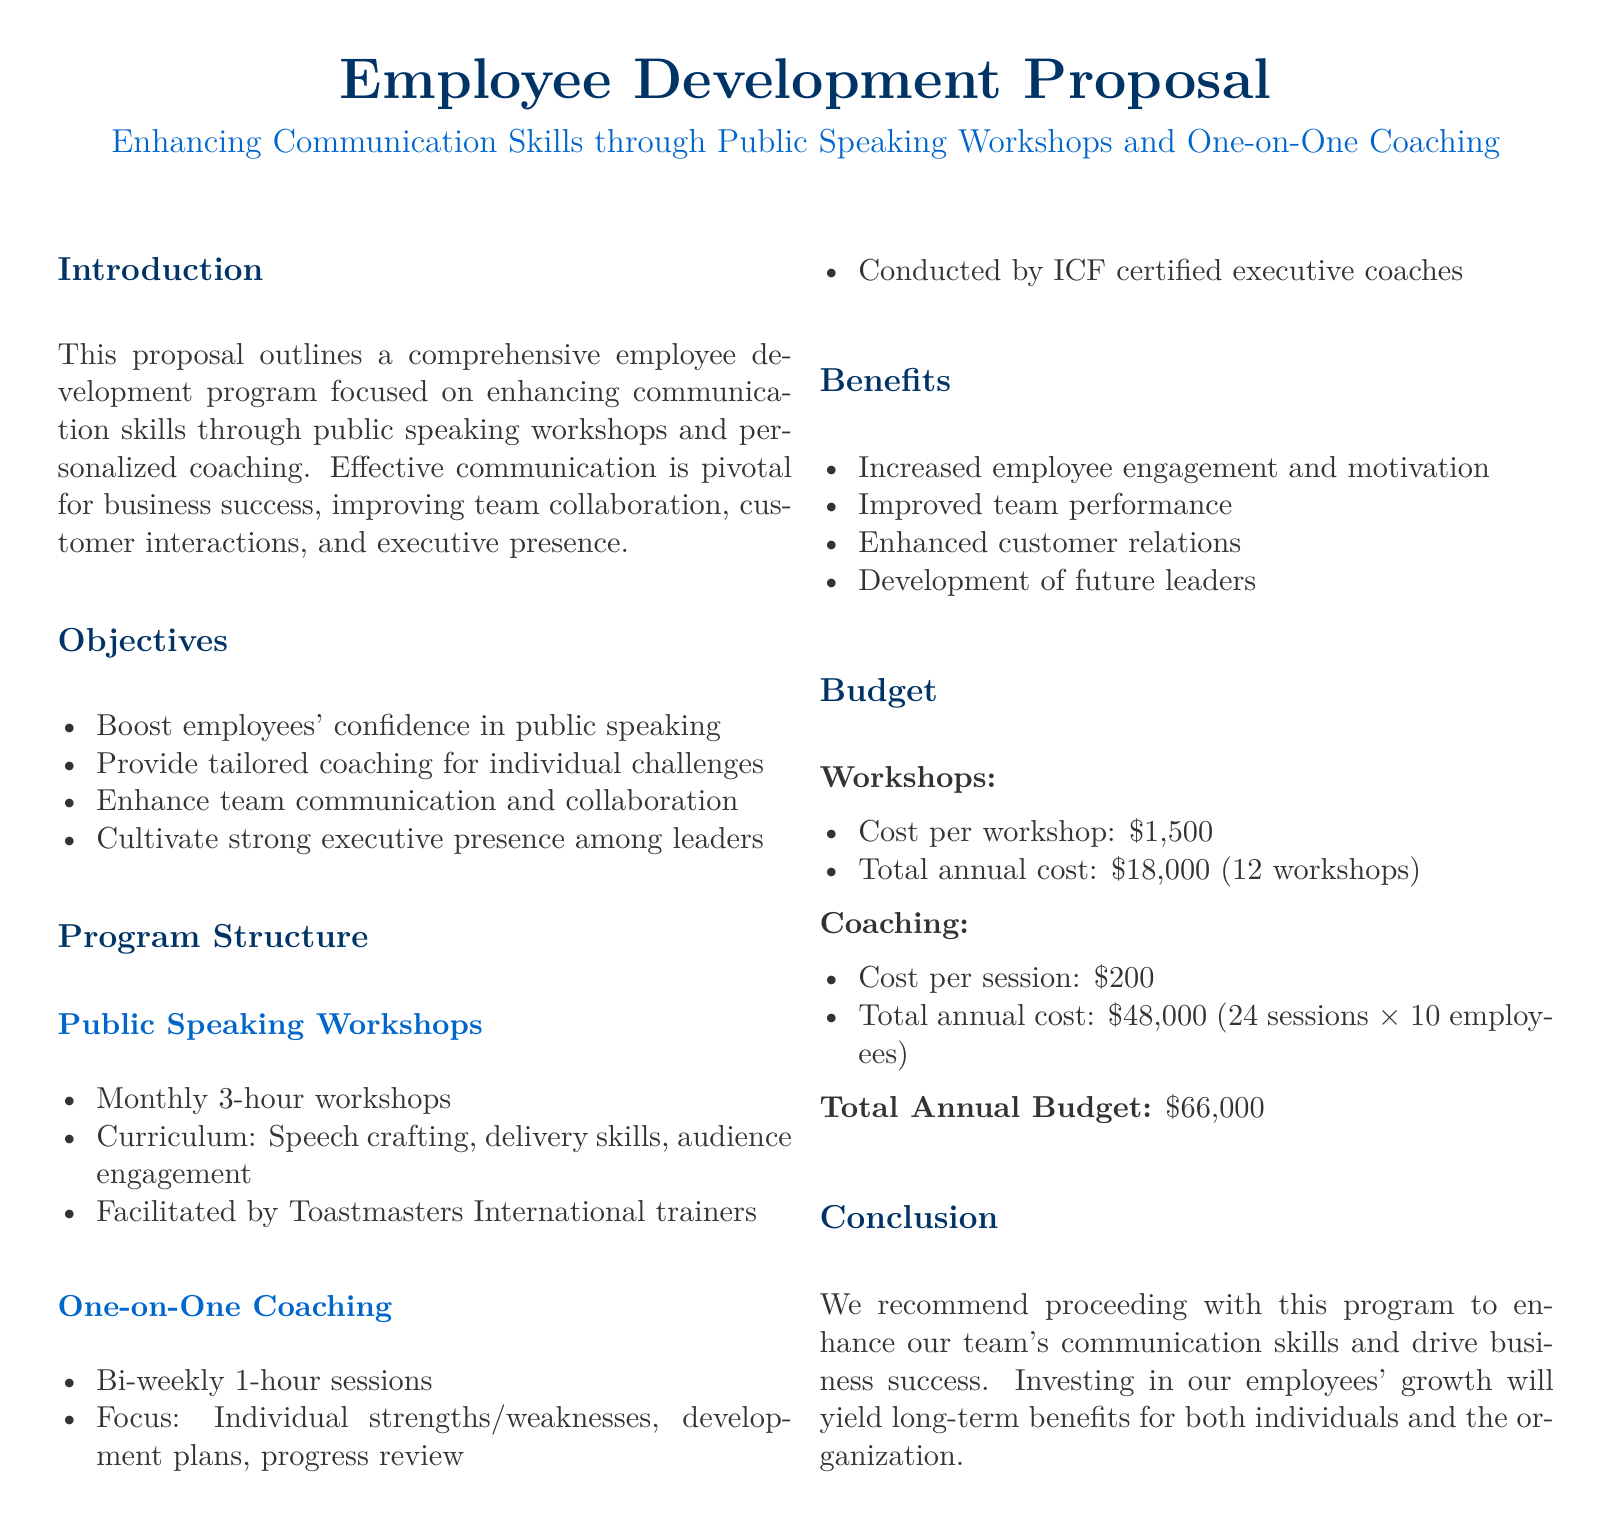What is the total annual budget for this program? The total annual budget is mentioned in the document as the sum of the costs for workshops and coaching. The workshops cost $18,000 and coaching costs $48,000, which totals $66,000.
Answer: $66,000 How many workshops are planned per year? The number of workshops is specified in the budget section where it states that there are 12 workshops planned for the year.
Answer: 12 What is the cost per one-on-one coaching session? The document provides the specific cost for each one-on-one coaching session, which is detailed in the coaching section.
Answer: $200 Who will facilitate the public speaking workshops? The facilitators of the public speaking workshops are mentioned in the program structure section, indicating that trainers from Toastmasters International will lead the sessions.
Answer: Toastmasters International trainers What is the focus of the one-on-one coaching sessions? The document outlines that the focus of the coaching sessions is on individual strengths and weaknesses, along with the development plans and progress reviews.
Answer: Individual strengths/weaknesses, development plans, progress review How often will the public speaking workshops be held? The frequency of the public speaking workshops is stated in the program structure section, indicating that they will be held monthly.
Answer: Monthly What is one of the objectives of this employee development program? The objectives listed in the document include boosting employees' confidence in public speaking, enhancing team communication, and cultivating executive presence.
Answer: Boost employees' confidence in public speaking How many bi-weekly coaching sessions are included for one employee over the year? The document mentions that there will be a total of 24 coaching sessions conducted over the year, for the specified number of employees.
Answer: 24 